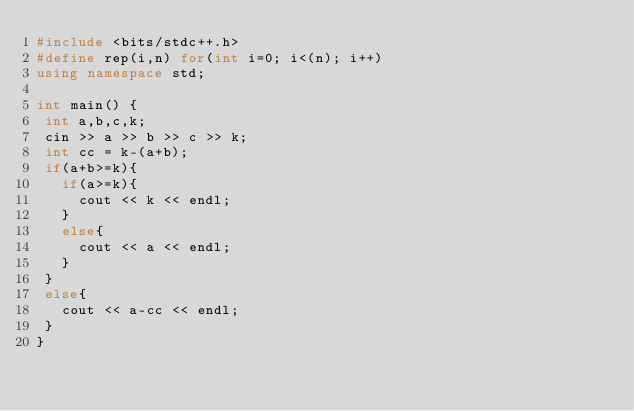Convert code to text. <code><loc_0><loc_0><loc_500><loc_500><_C++_>#include <bits/stdc++.h>
#define rep(i,n) for(int i=0; i<(n); i++)
using namespace std;

int main() {
 int a,b,c,k;
 cin >> a >> b >> c >> k;
 int cc = k-(a+b);
 if(a+b>=k){
   if(a>=k){
     cout << k << endl;
   }
   else{
     cout << a << endl;
   }
 }
 else{
   cout << a-cc << endl;
 }
}</code> 